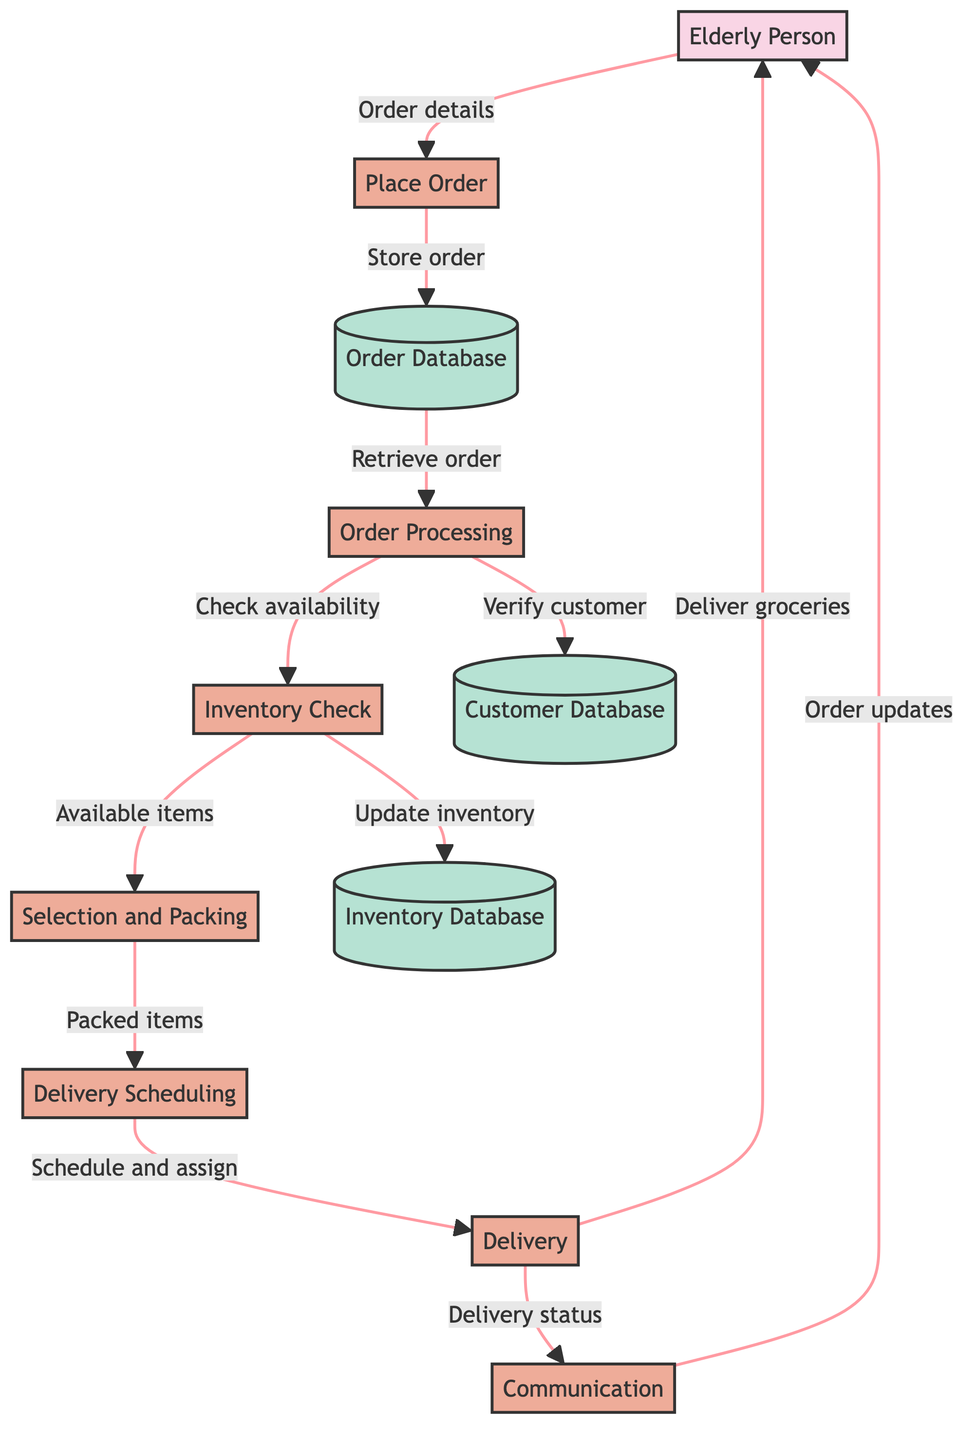What is the first process in the workflow? The first process in the diagram is indicated by the arrow leading from the elderly person to the "Place Order" process. This shows that placing the order is the initial step.
Answer: Place Order How many processes are represented in the diagram? By counting the boxes labeled as processes within the diagram, we find there are a total of six processes. Each process has its distinct role in the workflow of the grocery delivery service.
Answer: Six What does the "Delivery" process output? The "Delivery" process has two outgoing arrows: one leading to the "Elderly Person" indicating that groceries are delivered, and another towards "Communication," indicating delivery status feedback.
Answer: Deliver groceries Which data store contains customer details? The "Customer Database" is specifically mentioned in the diagram as containing the customer's personal details and order history, indicating its role in storing this information.
Answer: Customer Database What is the relationship between "Order Processing" and "Inventory Check"? The "Order Processing" process sends a flow to the "Inventory Check," indicating it checks the availability of items, which is an essential function connecting these two processes.
Answer: Checking item availability What type of information does the "Communication" process provide to the elderly person? The "Communication" process sends updates on order status and delivery information to the elderly person, indicating its role in keeping the customer informed.
Answer: Order updates Which process is responsible for verifying customer details? The "Order Processing" process is responsible for verifying customer details as indicated by the flow leading to the "Customer Database" to verify customer information and past orders.
Answer: Order Processing How does the "Selection and Packing" process interact with "Delivery Scheduling"? The "Selection and Packing" process provides information on the packed items to the "Delivery Scheduling" process, indicating its role in preparing for the delivery step.
Answer: Packed items What action does the "Inventory Check" process perform on the inventory database? The "Inventory Check" process updates the inventory status, showing that it modifies the Inventory Database based on the availability of items checked.
Answer: Updating inventory status 